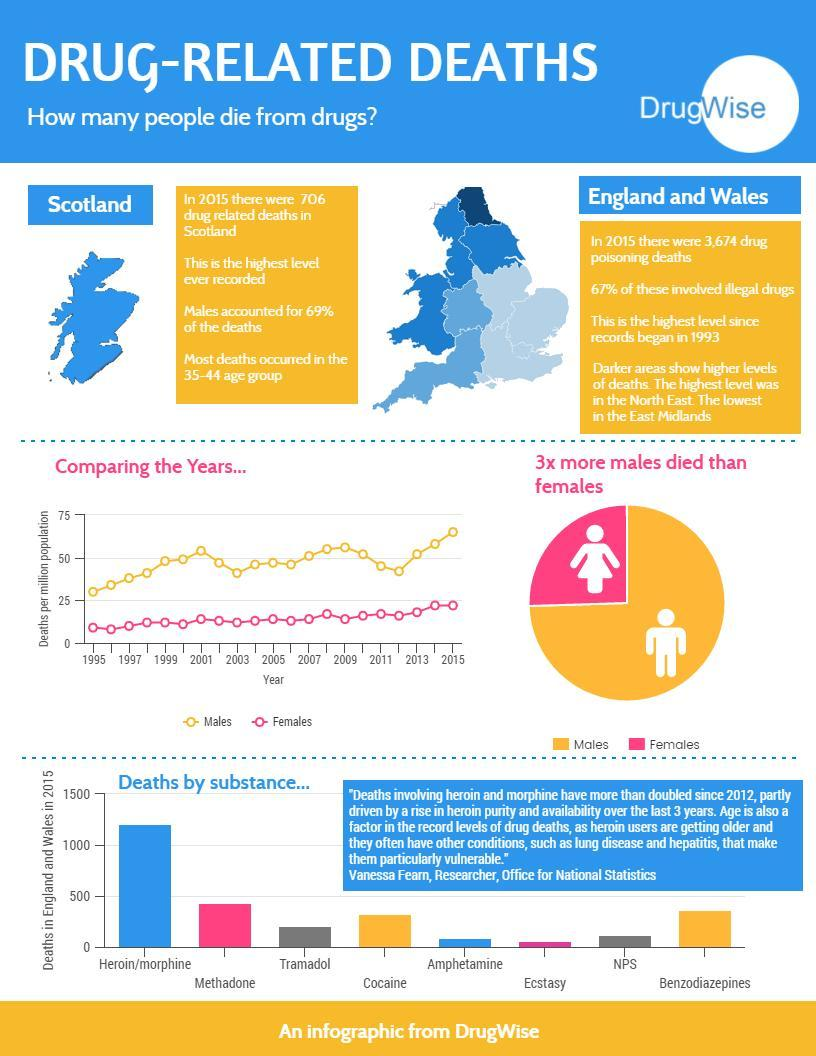The lowest death rate is for which substance?
Answer the question with a short phrase. Ecstasy Which color is used to represent males-red, pink, orange, or blue? orange Which color is used to represent females-red, pink, orange, or blue? pink How many years are in the graph? 11 